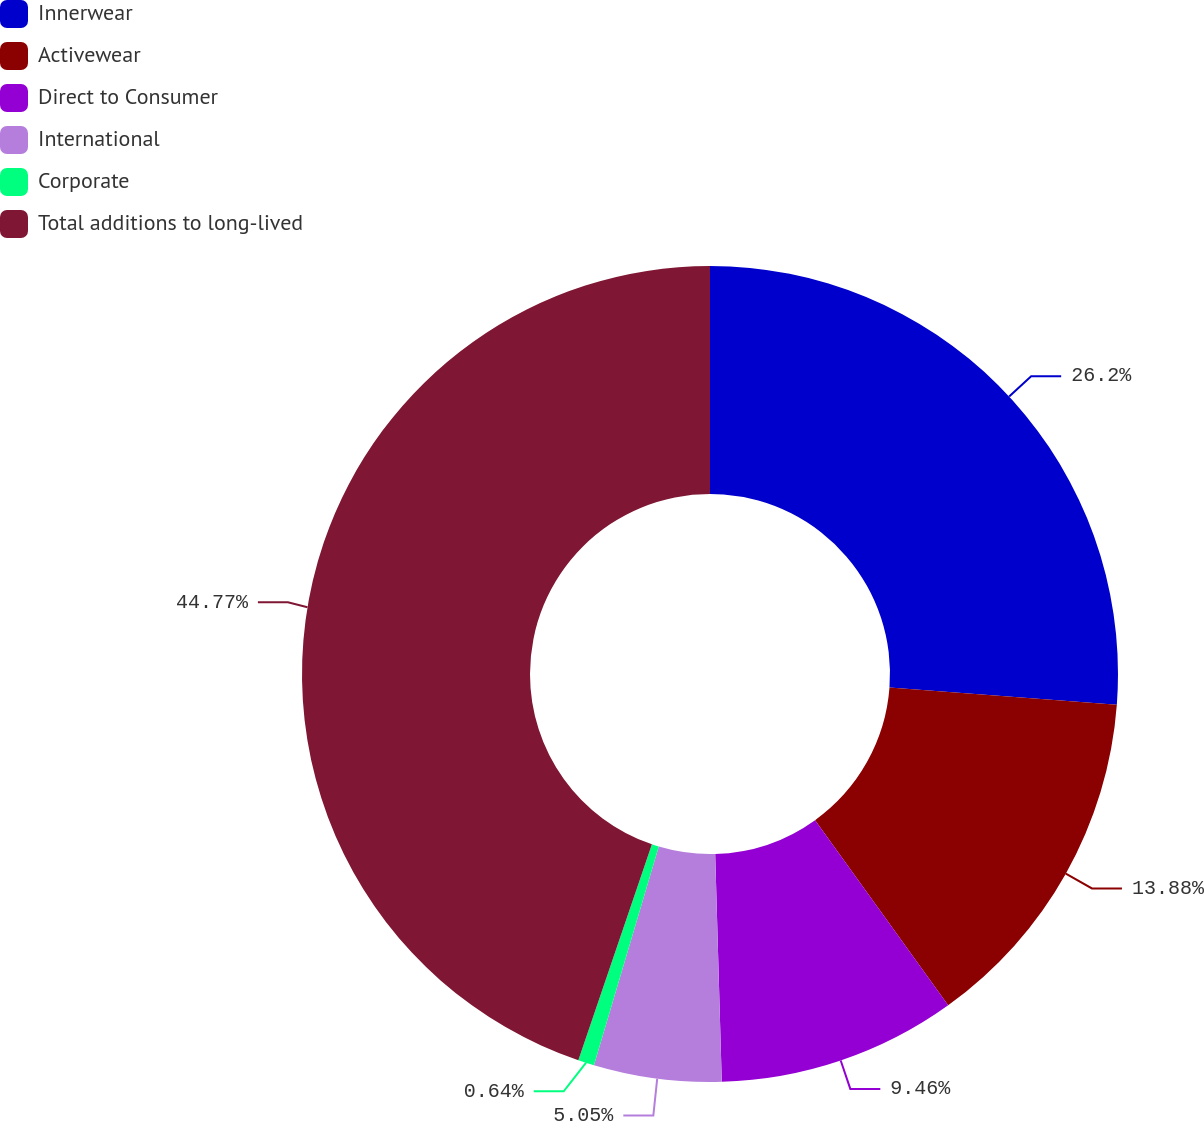Convert chart. <chart><loc_0><loc_0><loc_500><loc_500><pie_chart><fcel>Innerwear<fcel>Activewear<fcel>Direct to Consumer<fcel>International<fcel>Corporate<fcel>Total additions to long-lived<nl><fcel>26.2%<fcel>13.88%<fcel>9.46%<fcel>5.05%<fcel>0.64%<fcel>44.77%<nl></chart> 